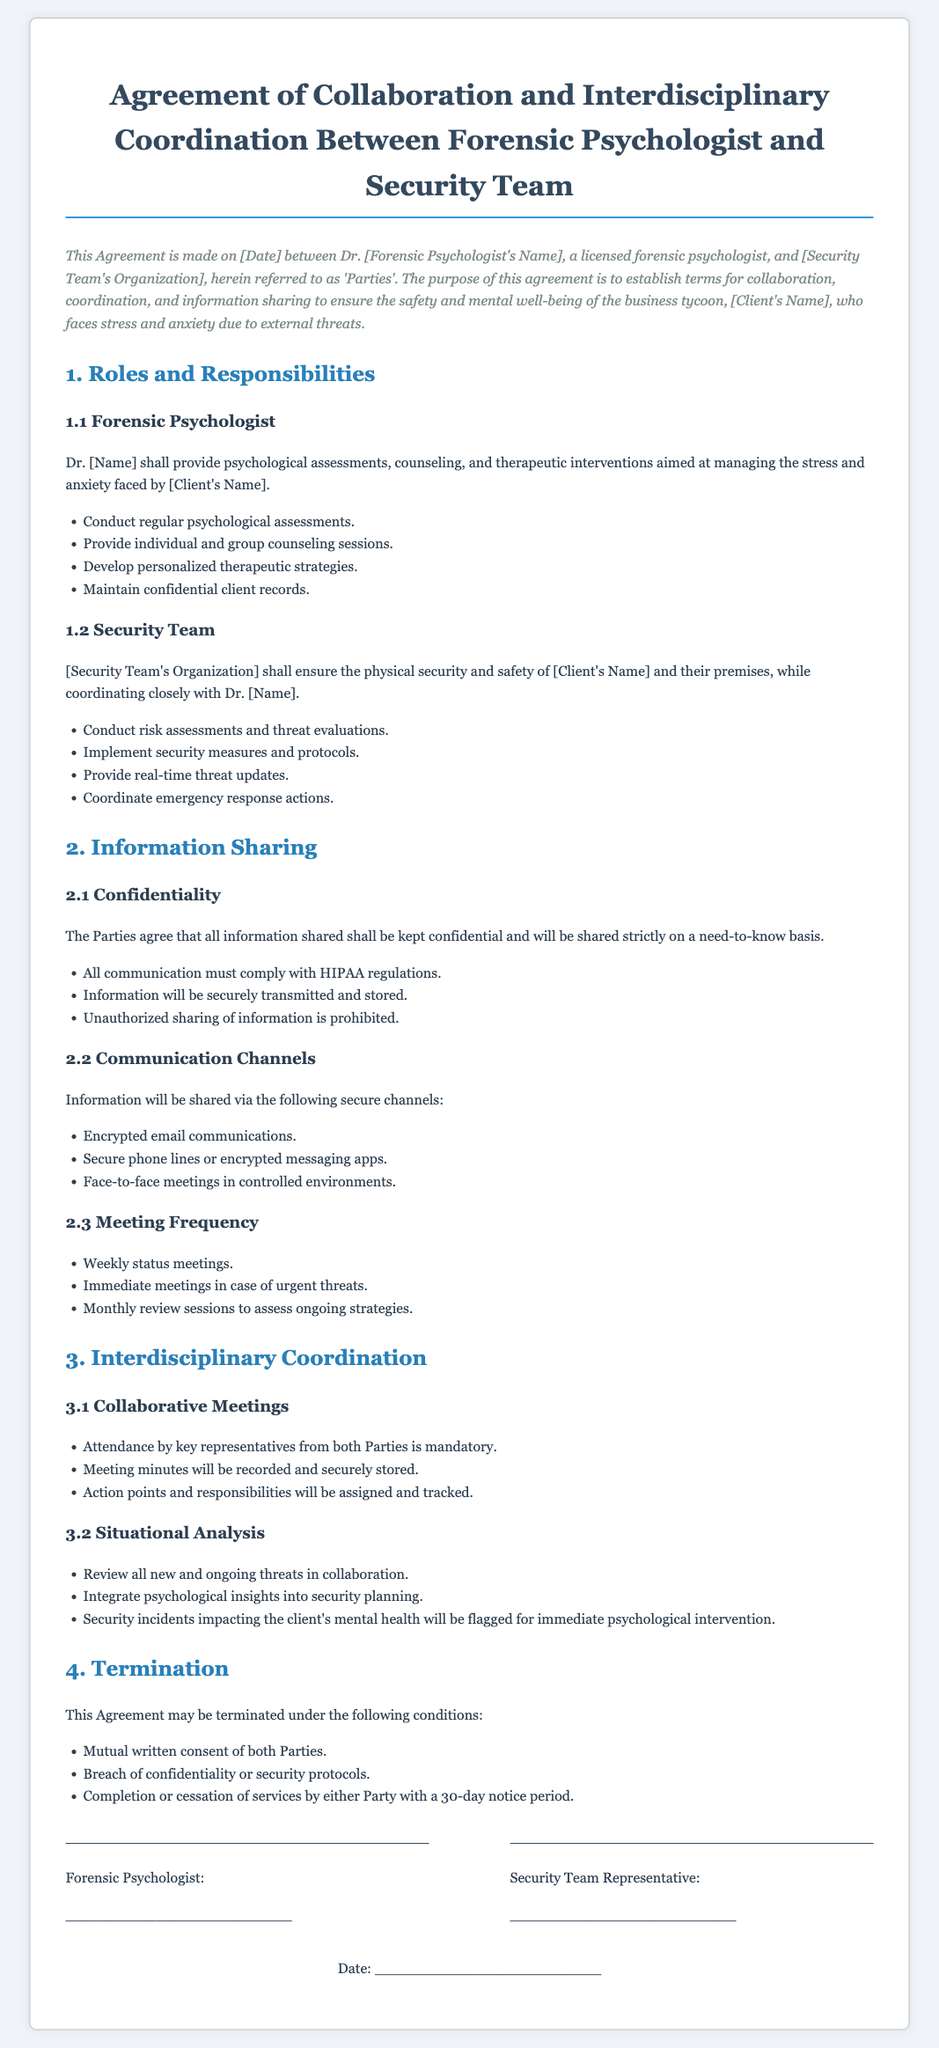What is the title of the document? The title is the heading of the contract, which outlines the nature of the agreement.
Answer: Agreement of Collaboration and Interdisciplinary Coordination Between Forensic Psychologist and Security Team Who are the parties involved in this agreement? The parties consist of a licensed forensic psychologist and a security team organization.
Answer: Dr. [Forensic Psychologist's Name] and [Security Team's Organization] What is one of the responsibilities of the forensic psychologist? This refers to one specific duty outlined for the forensic psychologist in the document.
Answer: Conduct regular psychological assessments What are the secure channels mentioned for information sharing? The secure communication methods are specified in the agreement.
Answer: Encrypted email communications How often are status meetings scheduled? This is a specific frequency mentioned for meetings in the agreement.
Answer: Weekly status meetings What may cause termination of this agreement? This question relates to the conditions under which the agreement can be concluded.
Answer: Breach of confidentiality or security protocols What must be recorded during collaborative meetings? This refers to specific documentation that is required during meetings as per the contract.
Answer: Meeting minutes What is a primary focus of the security team's responsibilities? This addresses the main objective given to the security team in the agreement.
Answer: Ensure the physical security and safety of [Client's Name] What action may take place if a security incident impacts the client's mental health? This relates to the immediate response outlined in the document regarding mental health interventions.
Answer: Flagged for immediate psychological intervention 